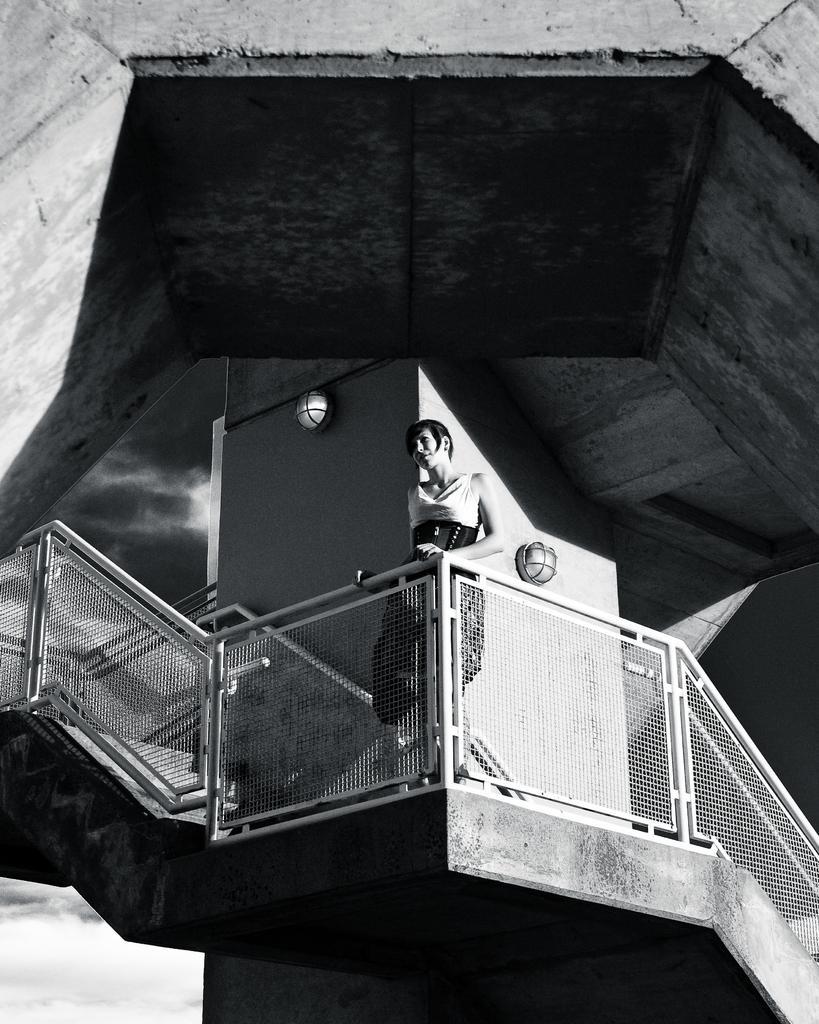How would you summarize this image in a sentence or two? In this image I can see a person is standing. I can see the fencing, pillar and sky. The image is in black and white. 